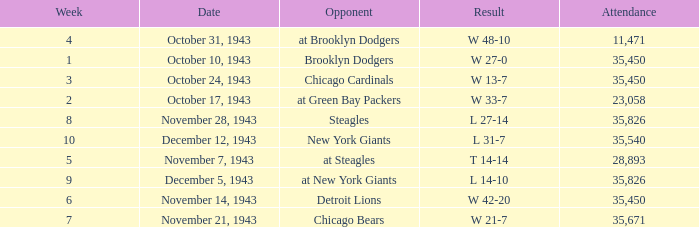What is the lowest attendance that has a week less than 4, and w 13-7 as the result? 35450.0. 